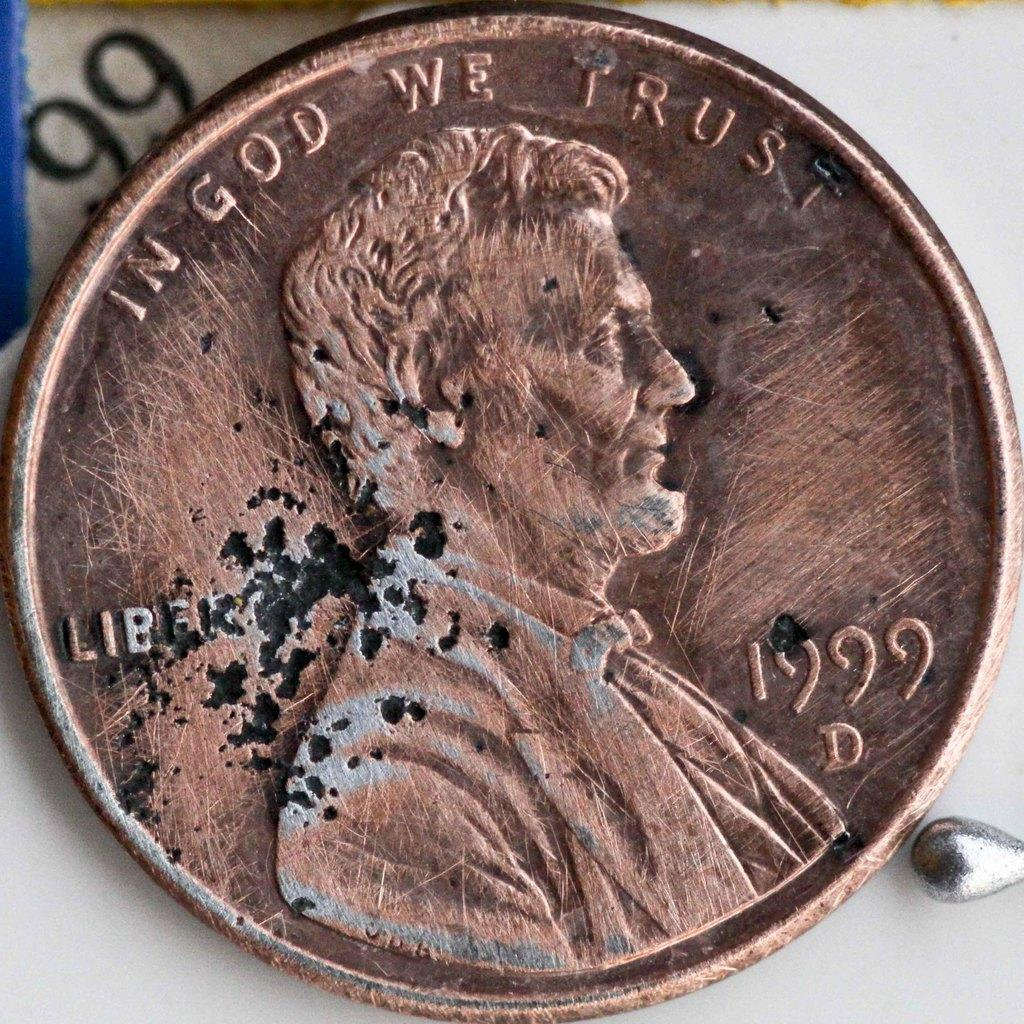<image>
Share a concise interpretation of the image provided. In God we trust brown penny from 1999 